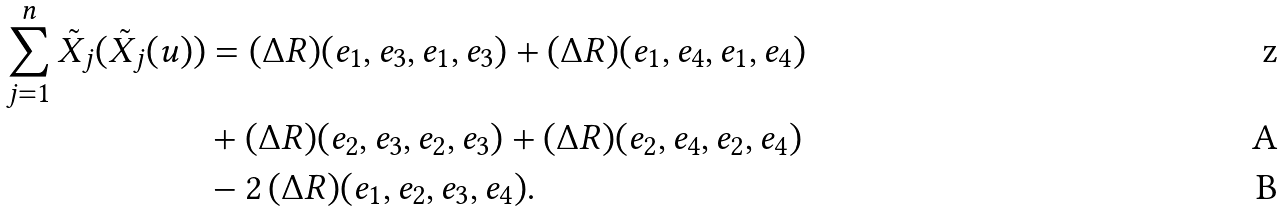<formula> <loc_0><loc_0><loc_500><loc_500>\sum _ { j = 1 } ^ { n } \tilde { X } _ { j } ( \tilde { X } _ { j } ( u ) ) & = ( \Delta R ) ( e _ { 1 } , e _ { 3 } , e _ { 1 } , e _ { 3 } ) + ( \Delta R ) ( e _ { 1 } , e _ { 4 } , e _ { 1 } , e _ { 4 } ) \\ & + ( \Delta R ) ( e _ { 2 } , e _ { 3 } , e _ { 2 } , e _ { 3 } ) + ( \Delta R ) ( e _ { 2 } , e _ { 4 } , e _ { 2 } , e _ { 4 } ) \\ & - 2 \, ( \Delta R ) ( e _ { 1 } , e _ { 2 } , e _ { 3 } , e _ { 4 } ) .</formula> 